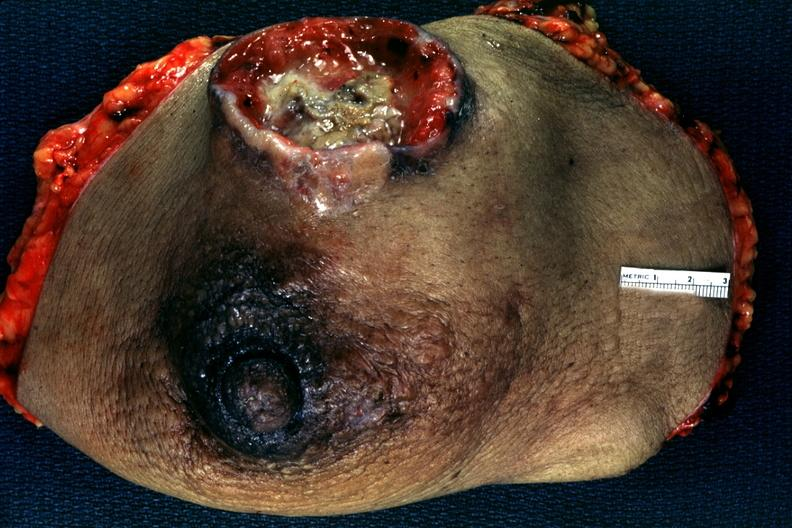does surface show large ulcerating carcinoma surgical specimen?
Answer the question using a single word or phrase. No 